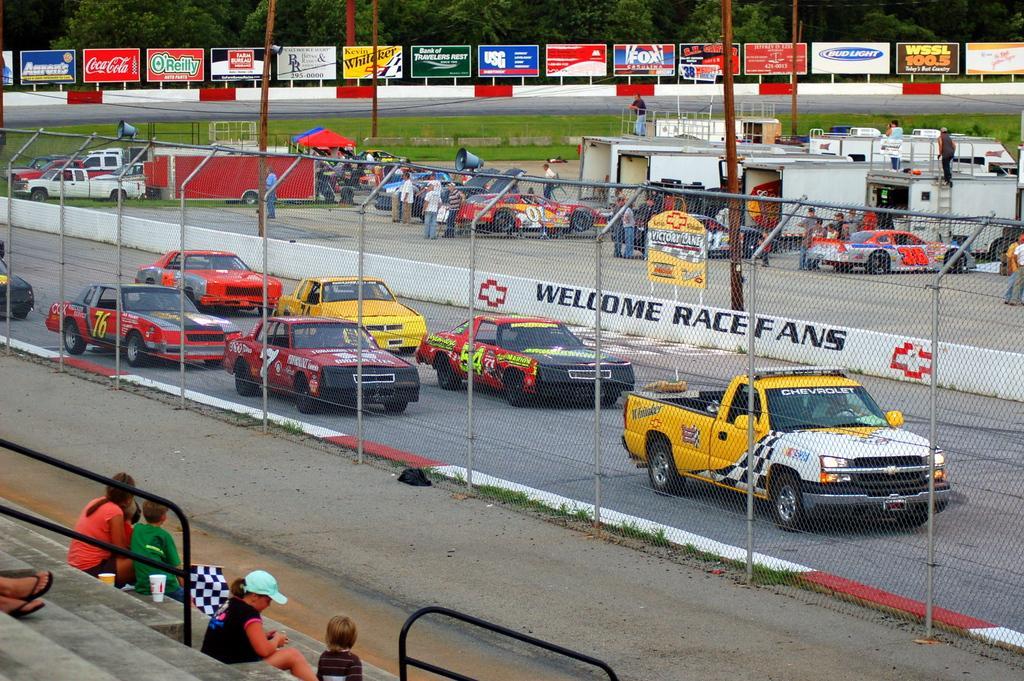Please provide a concise description of this image. In this picture I can see group of people sitting on the stairs, there is a person holding a flag, there are vehicles, there is fence, there are tents, boards, poles, megaphones and in the background there are trees. 